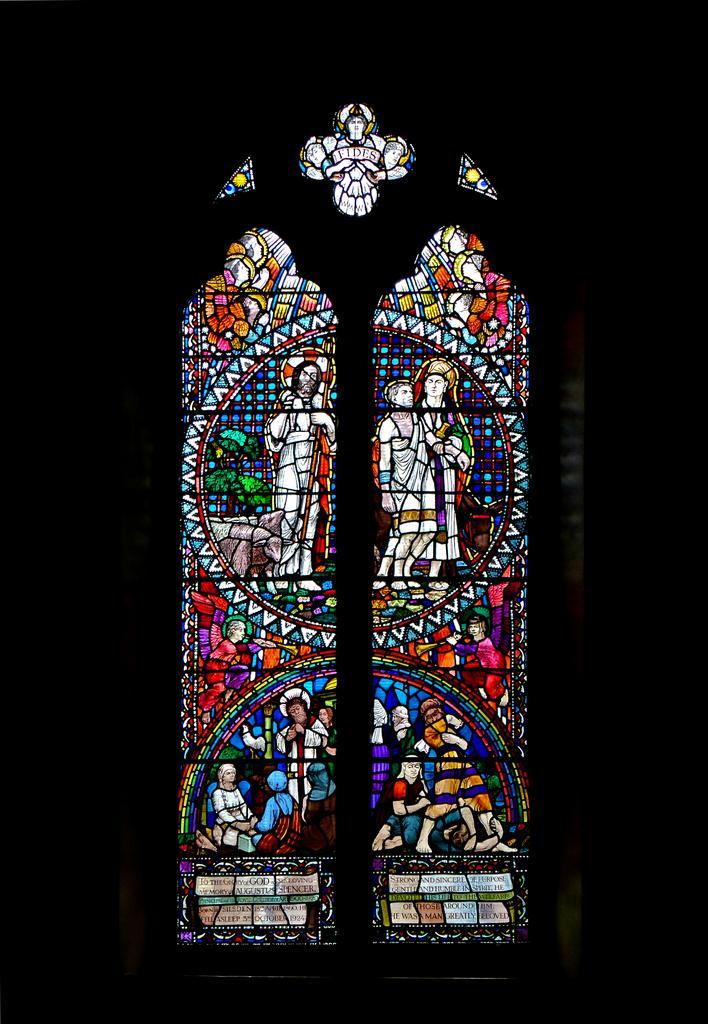In one or two sentences, can you explain what this image depicts? In this picture we can see a stained glass, there is a dark background. 